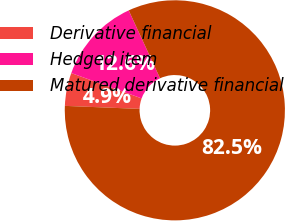Convert chart to OTSL. <chart><loc_0><loc_0><loc_500><loc_500><pie_chart><fcel>Derivative financial<fcel>Hedged item<fcel>Matured derivative financial<nl><fcel>4.85%<fcel>12.62%<fcel>82.52%<nl></chart> 